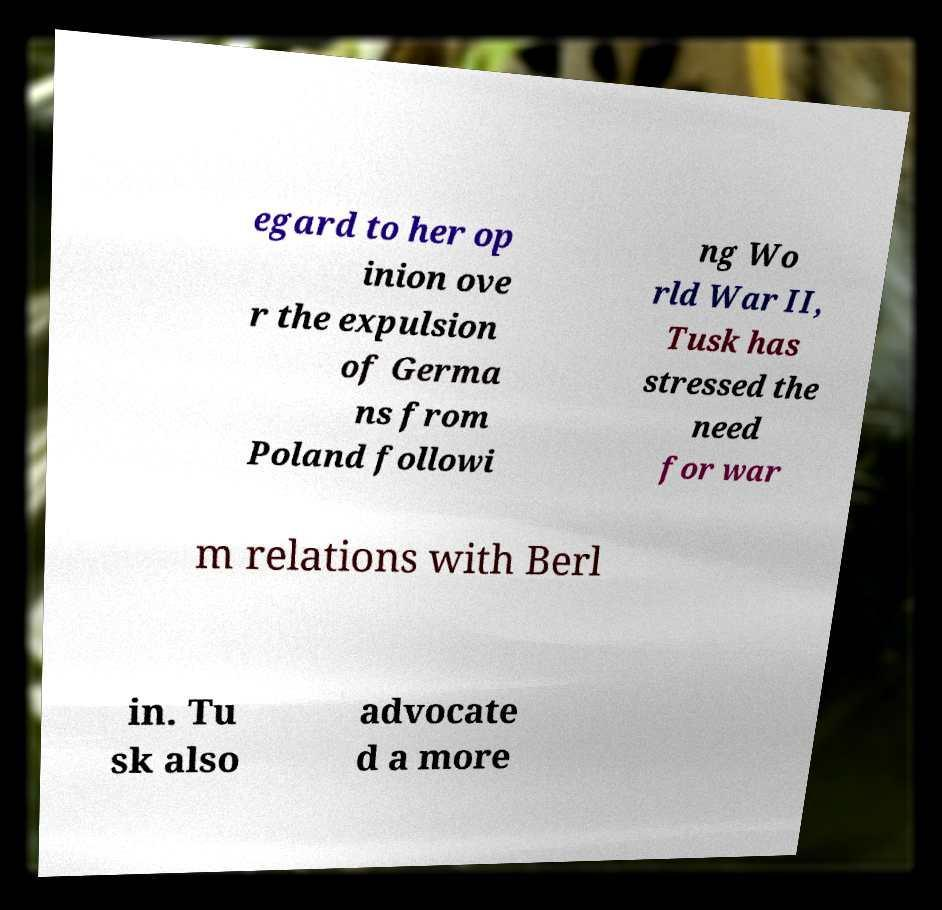What messages or text are displayed in this image? I need them in a readable, typed format. egard to her op inion ove r the expulsion of Germa ns from Poland followi ng Wo rld War II, Tusk has stressed the need for war m relations with Berl in. Tu sk also advocate d a more 